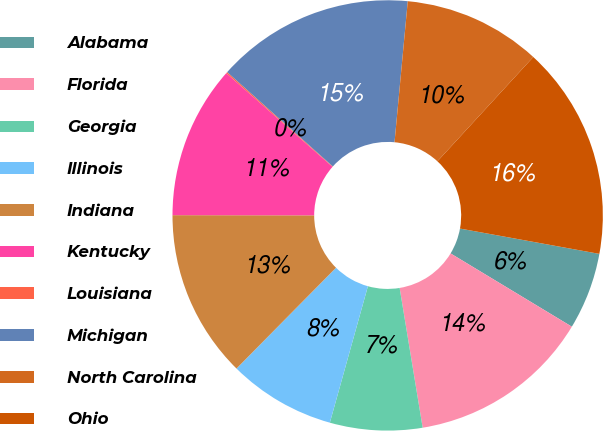Convert chart to OTSL. <chart><loc_0><loc_0><loc_500><loc_500><pie_chart><fcel>Alabama<fcel>Florida<fcel>Georgia<fcel>Illinois<fcel>Indiana<fcel>Kentucky<fcel>Louisiana<fcel>Michigan<fcel>North Carolina<fcel>Ohio<nl><fcel>5.79%<fcel>13.75%<fcel>6.93%<fcel>8.07%<fcel>12.62%<fcel>11.48%<fcel>0.1%<fcel>14.89%<fcel>10.34%<fcel>16.03%<nl></chart> 